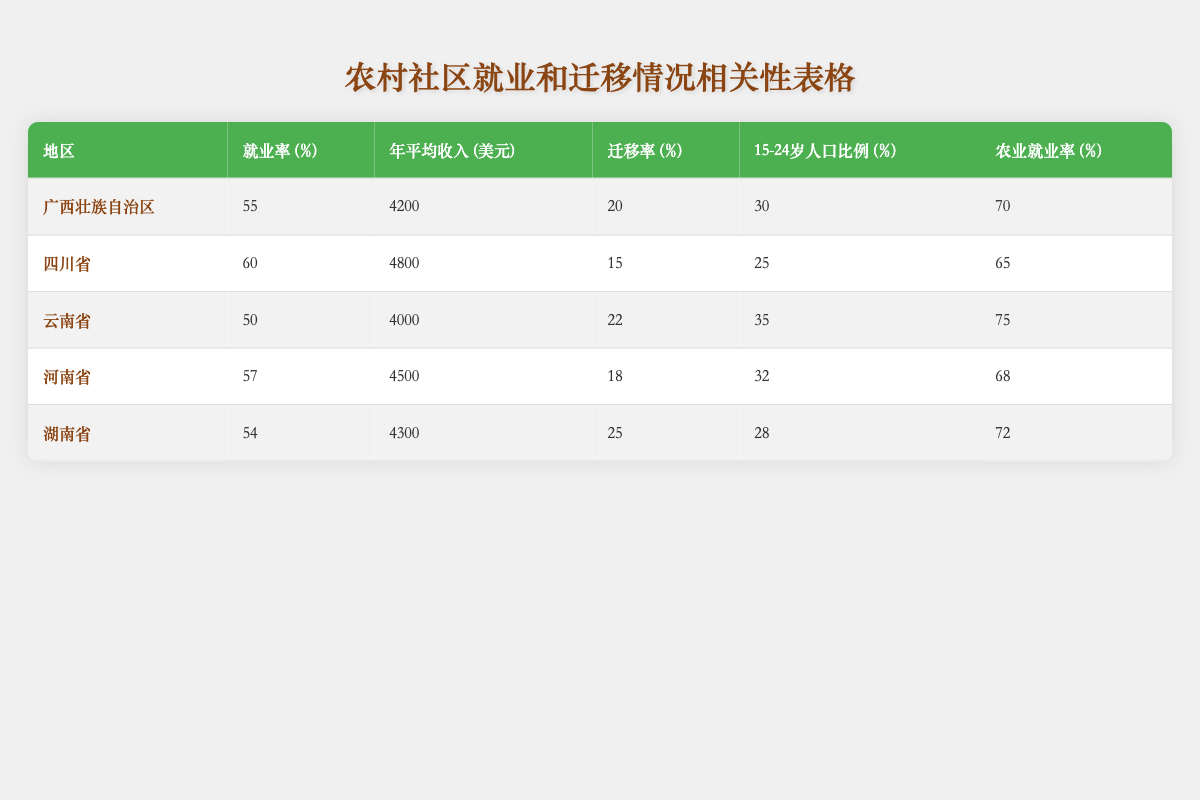What is the highest Employment Rate among the regions? Looking at the table, Sichuan Province has the highest Employment Rate at 60%.
Answer: 60% Which region has the lowest Average Annual Income? In the table, Yunnan Province has the lowest Average Annual Income at 4000 USD.
Answer: 4000 What is the total Migration Rate for all regions combined? Adding the Migration Rates from all regions: 20 + 15 + 22 + 18 + 25 = 100%.
Answer: 100% Is the Agricultural Employment Rate in Henan Province higher than the Employment Rate? The Employment Rate in Henan Province is 57%, while the Agricultural Employment Rate is 68%, which is higher.
Answer: Yes What is the average Employment Rate for the regions listed? The Employment Rates are 55, 60, 50, 57, and 54. The sum is 276, and there are 5 regions. The average is therefore 276/5 = 55.2.
Answer: 55.2 Which region has the highest Agricultural Employment Rate? Looking at the table, Yunnan Province has the highest Agricultural Employment Rate at 75%.
Answer: 75% Is it true that the Migration Rate in Hunan Province is higher than that in Sichuan Province? Hunan Province has a Migration Rate of 25% and Sichuan Province has 15%. Since 25 is greater than 15, this statement is true.
Answer: Yes Calculate the difference in Average Annual Income between the highest and lowest regions. The highest Average Annual Income is in Sichuan Province (4800 USD) and the lowest is in Yunnan Province (4000 USD). The difference is 4800 - 4000 = 800 USD.
Answer: 800 What percentage of the age group 15-24 is lowest in the regions listed? Looking closely, Hunan Province has the lowest percentage of the age group 15-24, at 28%.
Answer: 28% 